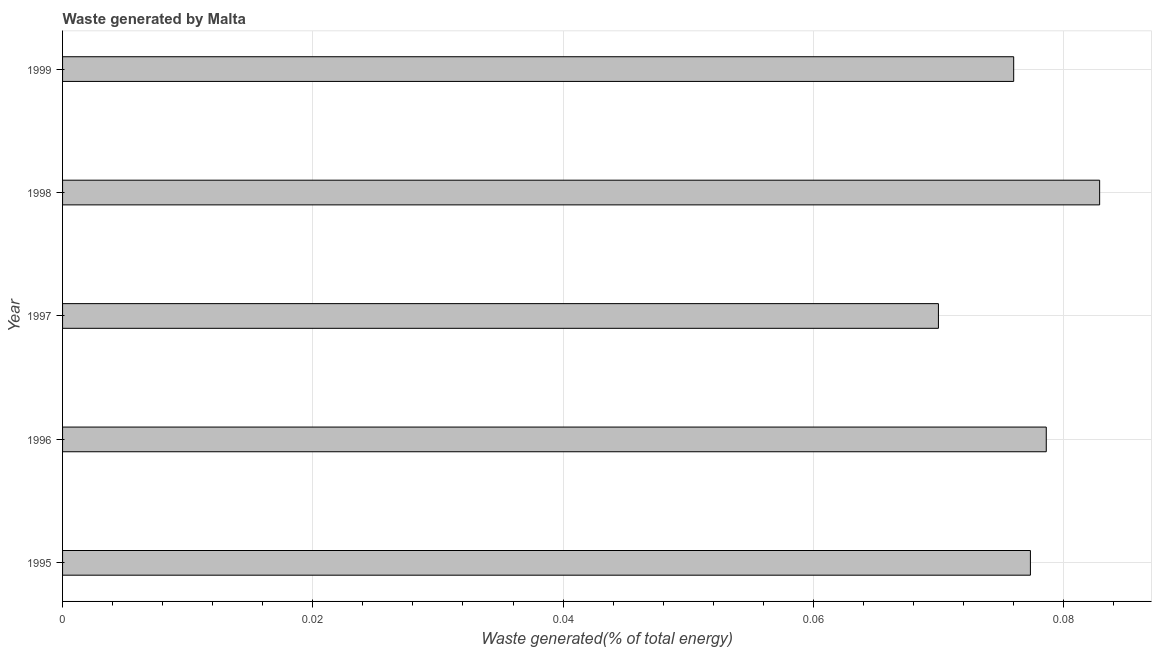Does the graph contain any zero values?
Provide a succinct answer. No. Does the graph contain grids?
Your answer should be compact. Yes. What is the title of the graph?
Your answer should be compact. Waste generated by Malta. What is the label or title of the X-axis?
Provide a succinct answer. Waste generated(% of total energy). What is the amount of waste generated in 1996?
Your answer should be compact. 0.08. Across all years, what is the maximum amount of waste generated?
Make the answer very short. 0.08. Across all years, what is the minimum amount of waste generated?
Keep it short and to the point. 0.07. In which year was the amount of waste generated maximum?
Offer a terse response. 1998. In which year was the amount of waste generated minimum?
Your answer should be very brief. 1997. What is the sum of the amount of waste generated?
Offer a very short reply. 0.38. What is the difference between the amount of waste generated in 1995 and 1996?
Offer a very short reply. -0. What is the average amount of waste generated per year?
Offer a very short reply. 0.08. What is the median amount of waste generated?
Your answer should be compact. 0.08. In how many years, is the amount of waste generated greater than 0.076 %?
Offer a very short reply. 4. What is the ratio of the amount of waste generated in 1997 to that in 1999?
Offer a terse response. 0.92. Is the amount of waste generated in 1995 less than that in 1999?
Your answer should be very brief. No. What is the difference between the highest and the second highest amount of waste generated?
Provide a succinct answer. 0. Is the sum of the amount of waste generated in 1995 and 1997 greater than the maximum amount of waste generated across all years?
Your response must be concise. Yes. In how many years, is the amount of waste generated greater than the average amount of waste generated taken over all years?
Ensure brevity in your answer.  3. How many bars are there?
Offer a terse response. 5. Are all the bars in the graph horizontal?
Keep it short and to the point. Yes. What is the Waste generated(% of total energy) in 1995?
Your response must be concise. 0.08. What is the Waste generated(% of total energy) of 1996?
Make the answer very short. 0.08. What is the Waste generated(% of total energy) in 1997?
Ensure brevity in your answer.  0.07. What is the Waste generated(% of total energy) in 1998?
Make the answer very short. 0.08. What is the Waste generated(% of total energy) of 1999?
Provide a short and direct response. 0.08. What is the difference between the Waste generated(% of total energy) in 1995 and 1996?
Your response must be concise. -0. What is the difference between the Waste generated(% of total energy) in 1995 and 1997?
Offer a terse response. 0.01. What is the difference between the Waste generated(% of total energy) in 1995 and 1998?
Give a very brief answer. -0.01. What is the difference between the Waste generated(% of total energy) in 1995 and 1999?
Provide a short and direct response. 0. What is the difference between the Waste generated(% of total energy) in 1996 and 1997?
Make the answer very short. 0.01. What is the difference between the Waste generated(% of total energy) in 1996 and 1998?
Ensure brevity in your answer.  -0. What is the difference between the Waste generated(% of total energy) in 1996 and 1999?
Your answer should be compact. 0. What is the difference between the Waste generated(% of total energy) in 1997 and 1998?
Your response must be concise. -0.01. What is the difference between the Waste generated(% of total energy) in 1997 and 1999?
Give a very brief answer. -0.01. What is the difference between the Waste generated(% of total energy) in 1998 and 1999?
Make the answer very short. 0.01. What is the ratio of the Waste generated(% of total energy) in 1995 to that in 1997?
Provide a short and direct response. 1.1. What is the ratio of the Waste generated(% of total energy) in 1995 to that in 1998?
Offer a very short reply. 0.93. What is the ratio of the Waste generated(% of total energy) in 1996 to that in 1997?
Give a very brief answer. 1.12. What is the ratio of the Waste generated(% of total energy) in 1996 to that in 1998?
Keep it short and to the point. 0.95. What is the ratio of the Waste generated(% of total energy) in 1996 to that in 1999?
Ensure brevity in your answer.  1.03. What is the ratio of the Waste generated(% of total energy) in 1997 to that in 1998?
Keep it short and to the point. 0.84. What is the ratio of the Waste generated(% of total energy) in 1997 to that in 1999?
Make the answer very short. 0.92. What is the ratio of the Waste generated(% of total energy) in 1998 to that in 1999?
Offer a terse response. 1.09. 